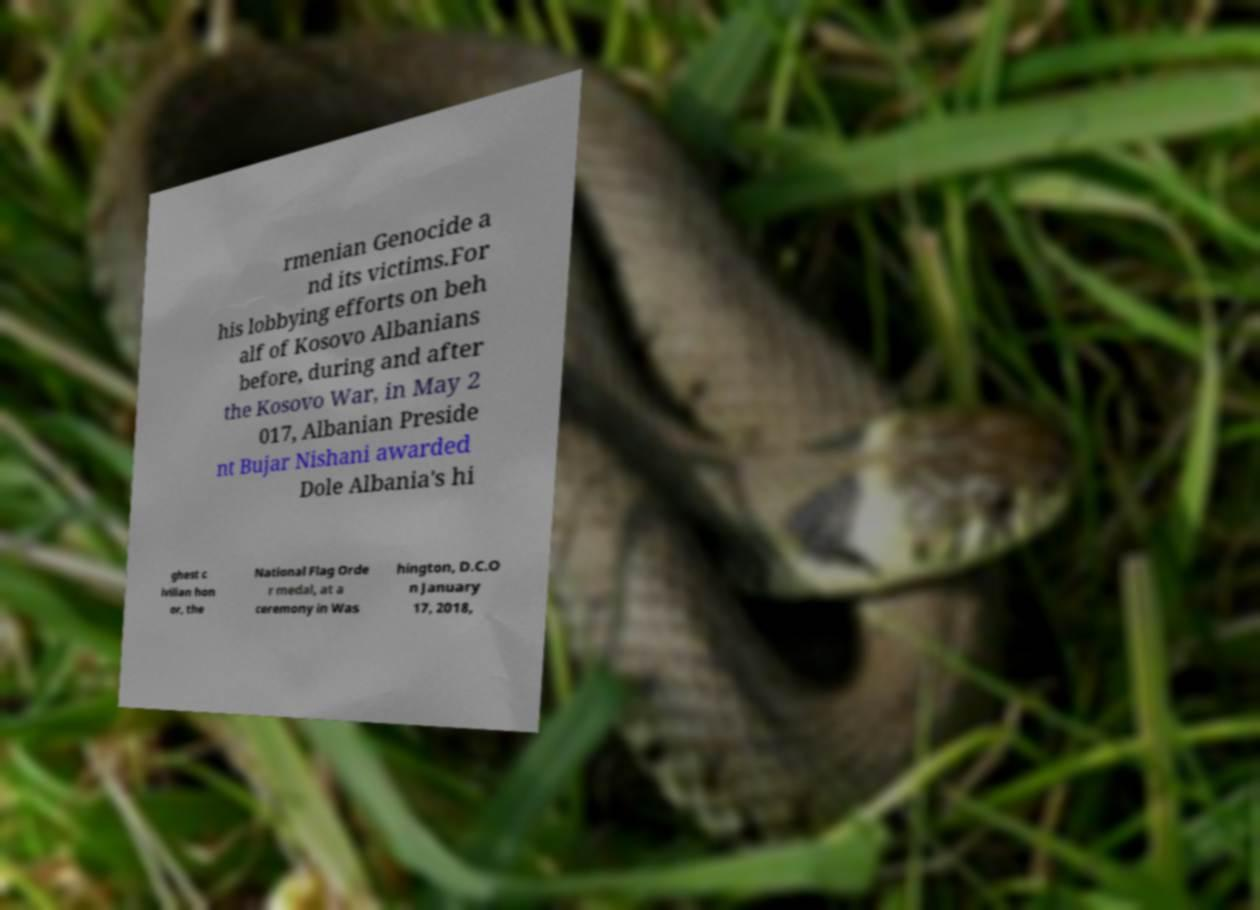Please read and relay the text visible in this image. What does it say? rmenian Genocide a nd its victims.For his lobbying efforts on beh alf of Kosovo Albanians before, during and after the Kosovo War, in May 2 017, Albanian Preside nt Bujar Nishani awarded Dole Albania's hi ghest c ivilian hon or, the National Flag Orde r medal, at a ceremony in Was hington, D.C.O n January 17, 2018, 